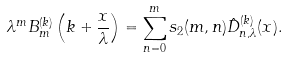<formula> <loc_0><loc_0><loc_500><loc_500>\lambda ^ { m } B _ { m } ^ { ( k ) } \left ( k + \frac { x } { \lambda } \right ) = \sum _ { n = 0 } ^ { m } s _ { 2 } ( m , n ) \hat { D } _ { n , \lambda } ^ { ( k ) } ( x ) .</formula> 